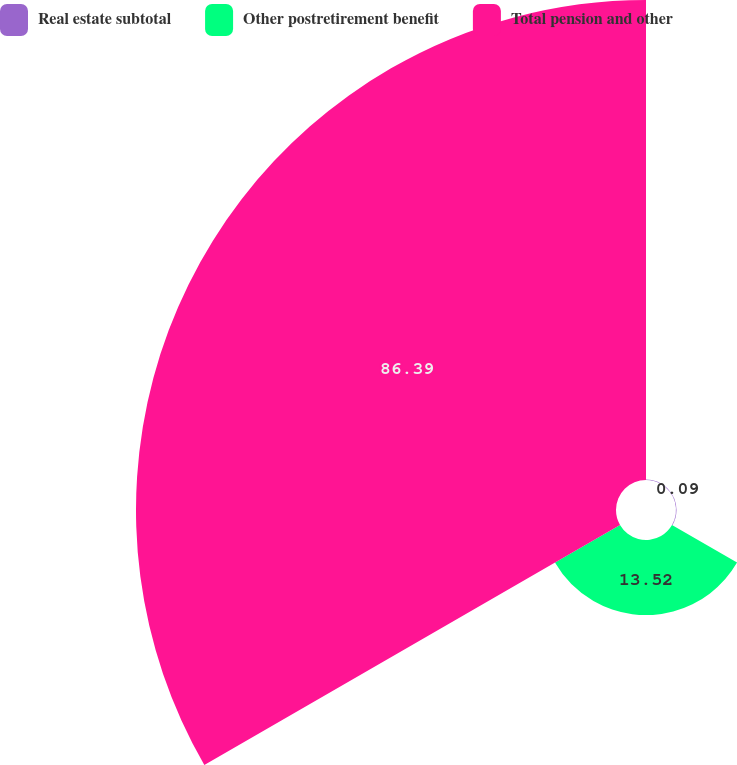Convert chart. <chart><loc_0><loc_0><loc_500><loc_500><pie_chart><fcel>Real estate subtotal<fcel>Other postretirement benefit<fcel>Total pension and other<nl><fcel>0.09%<fcel>13.52%<fcel>86.39%<nl></chart> 